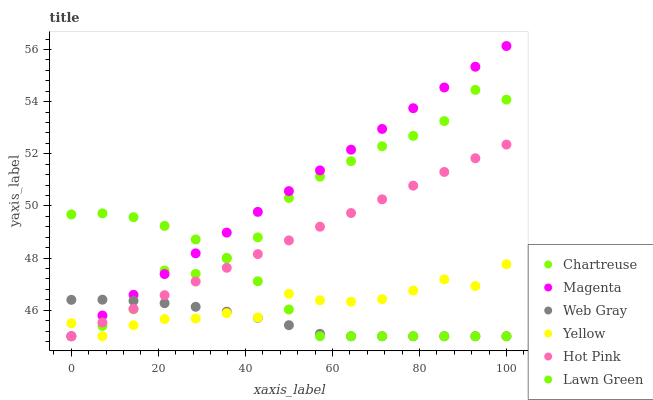Does Web Gray have the minimum area under the curve?
Answer yes or no. Yes. Does Magenta have the maximum area under the curve?
Answer yes or no. Yes. Does Hot Pink have the minimum area under the curve?
Answer yes or no. No. Does Hot Pink have the maximum area under the curve?
Answer yes or no. No. Is Magenta the smoothest?
Answer yes or no. Yes. Is Chartreuse the roughest?
Answer yes or no. Yes. Is Web Gray the smoothest?
Answer yes or no. No. Is Web Gray the roughest?
Answer yes or no. No. Does Lawn Green have the lowest value?
Answer yes or no. Yes. Does Magenta have the highest value?
Answer yes or no. Yes. Does Hot Pink have the highest value?
Answer yes or no. No. Does Hot Pink intersect Magenta?
Answer yes or no. Yes. Is Hot Pink less than Magenta?
Answer yes or no. No. Is Hot Pink greater than Magenta?
Answer yes or no. No. 